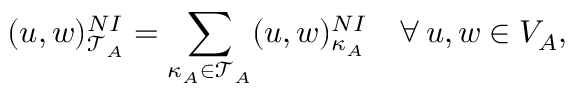Convert formula to latex. <formula><loc_0><loc_0><loc_500><loc_500>( u , w ) _ { \mathcal { T } _ { A } } ^ { N I } = \sum _ { \kappa _ { A } \in \mathcal { T } _ { A } } ( u , w ) _ { \kappa _ { A } } ^ { N I } \quad \forall \, u , w \in V _ { A } ,</formula> 